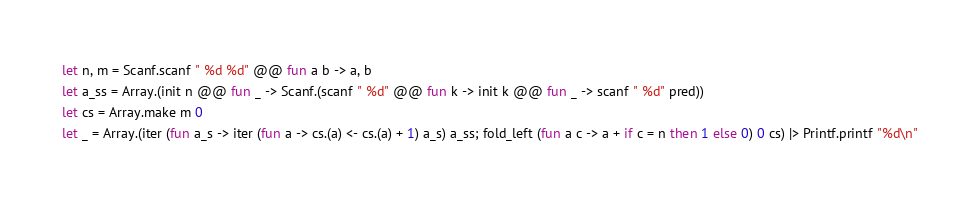<code> <loc_0><loc_0><loc_500><loc_500><_OCaml_>let n, m = Scanf.scanf " %d %d" @@ fun a b -> a, b
let a_ss = Array.(init n @@ fun _ -> Scanf.(scanf " %d" @@ fun k -> init k @@ fun _ -> scanf " %d" pred))
let cs = Array.make m 0
let _ = Array.(iter (fun a_s -> iter (fun a -> cs.(a) <- cs.(a) + 1) a_s) a_ss; fold_left (fun a c -> a + if c = n then 1 else 0) 0 cs) |> Printf.printf "%d\n"</code> 